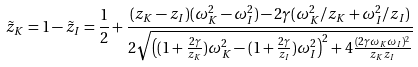<formula> <loc_0><loc_0><loc_500><loc_500>\tilde { z } _ { K } = 1 - \tilde { z } _ { I } = \frac { 1 } { 2 } + \frac { ( z _ { K } - z _ { I } ) ( \omega _ { K } ^ { 2 } - \omega _ { I } ^ { 2 } ) - 2 \gamma ( \omega _ { K } ^ { 2 } / z _ { K } + \omega _ { I } ^ { 2 } / z _ { I } ) } { 2 \sqrt { \left ( ( 1 + \frac { 2 \gamma } { z _ { K } } ) \omega _ { K } ^ { 2 } - ( 1 + \frac { 2 \gamma } { z _ { I } } ) \omega _ { I } ^ { 2 } \right ) ^ { 2 } + 4 \frac { ( 2 \gamma \omega _ { K } \omega _ { I } ) ^ { 2 } } { z _ { K } z _ { I } } } }</formula> 